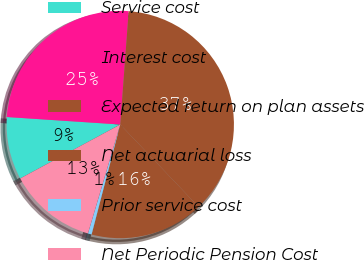Convert chart. <chart><loc_0><loc_0><loc_500><loc_500><pie_chart><fcel>Service cost<fcel>Interest cost<fcel>Expected return on plan assets<fcel>Net actuarial loss<fcel>Prior service cost<fcel>Net Periodic Pension Cost<nl><fcel>8.92%<fcel>25.13%<fcel>36.71%<fcel>16.16%<fcel>0.53%<fcel>12.54%<nl></chart> 